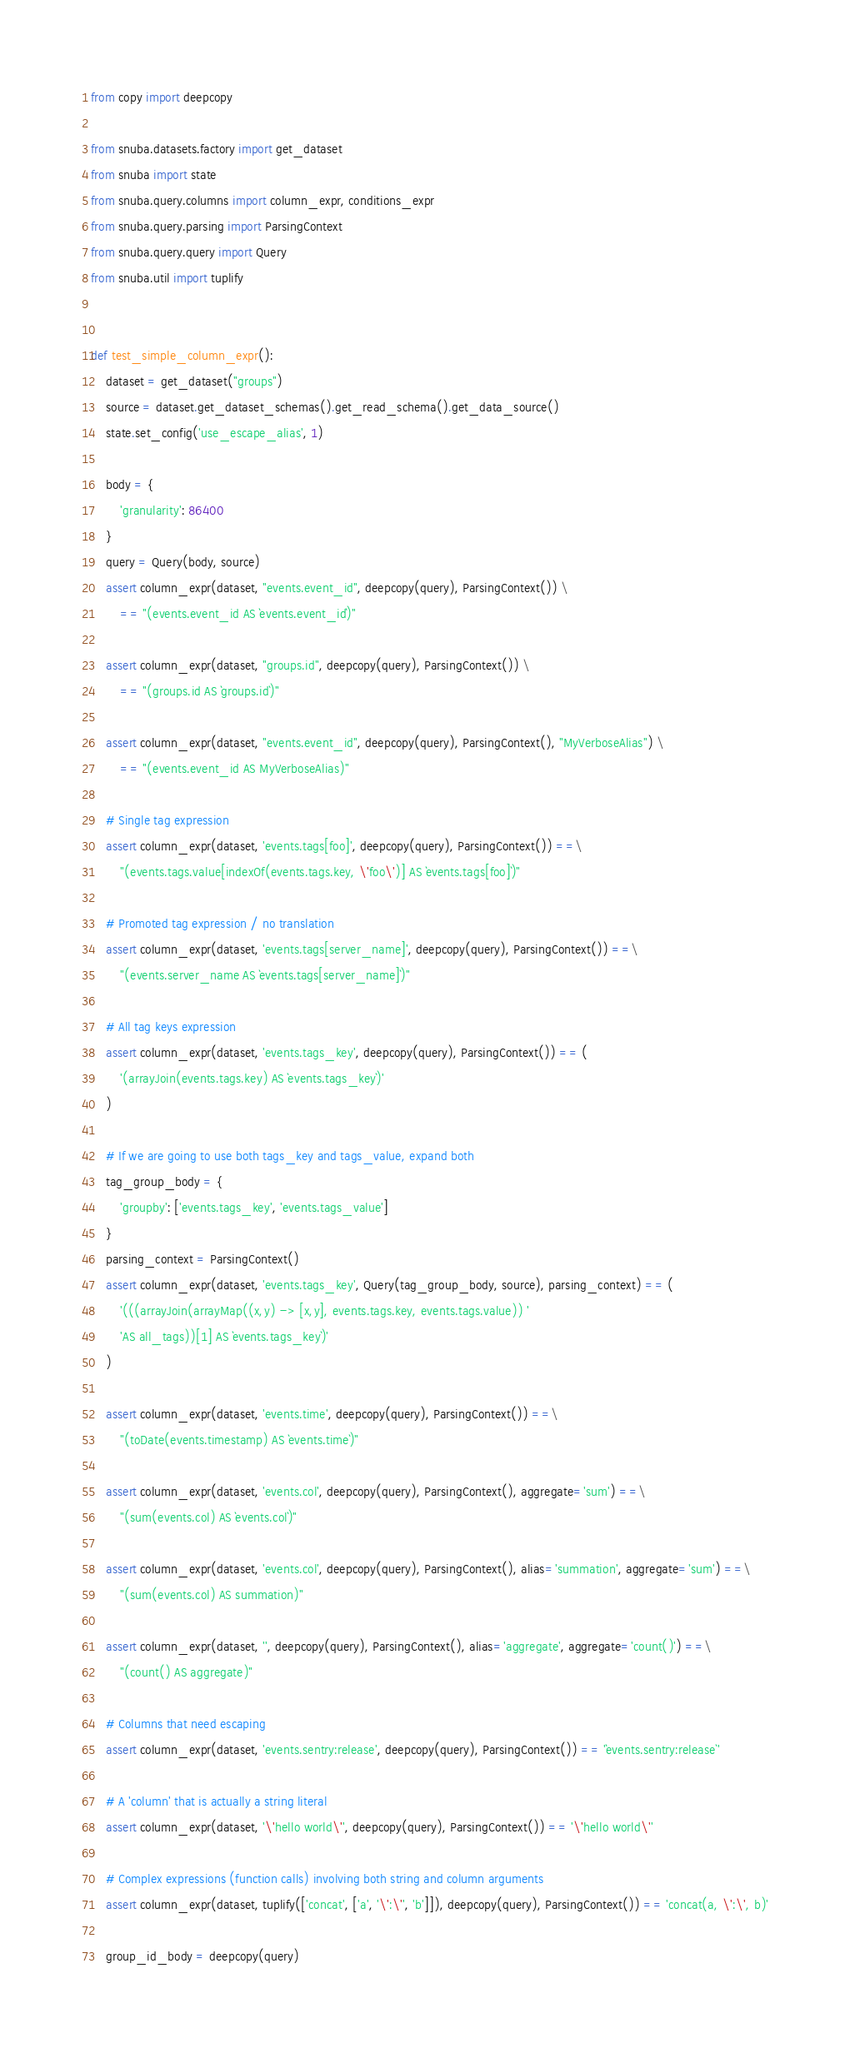<code> <loc_0><loc_0><loc_500><loc_500><_Python_>from copy import deepcopy

from snuba.datasets.factory import get_dataset
from snuba import state
from snuba.query.columns import column_expr, conditions_expr
from snuba.query.parsing import ParsingContext
from snuba.query.query import Query
from snuba.util import tuplify


def test_simple_column_expr():
    dataset = get_dataset("groups")
    source = dataset.get_dataset_schemas().get_read_schema().get_data_source()
    state.set_config('use_escape_alias', 1)

    body = {
        'granularity': 86400
    }
    query = Query(body, source)
    assert column_expr(dataset, "events.event_id", deepcopy(query), ParsingContext()) \
        == "(events.event_id AS `events.event_id`)"

    assert column_expr(dataset, "groups.id", deepcopy(query), ParsingContext()) \
        == "(groups.id AS `groups.id`)"

    assert column_expr(dataset, "events.event_id", deepcopy(query), ParsingContext(), "MyVerboseAlias") \
        == "(events.event_id AS MyVerboseAlias)"

    # Single tag expression
    assert column_expr(dataset, 'events.tags[foo]', deepcopy(query), ParsingContext()) ==\
        "(events.tags.value[indexOf(events.tags.key, \'foo\')] AS `events.tags[foo]`)"

    # Promoted tag expression / no translation
    assert column_expr(dataset, 'events.tags[server_name]', deepcopy(query), ParsingContext()) ==\
        "(events.server_name AS `events.tags[server_name]`)"

    # All tag keys expression
    assert column_expr(dataset, 'events.tags_key', deepcopy(query), ParsingContext()) == (
        '(arrayJoin(events.tags.key) AS `events.tags_key`)'
    )

    # If we are going to use both tags_key and tags_value, expand both
    tag_group_body = {
        'groupby': ['events.tags_key', 'events.tags_value']
    }
    parsing_context = ParsingContext()
    assert column_expr(dataset, 'events.tags_key', Query(tag_group_body, source), parsing_context) == (
        '(((arrayJoin(arrayMap((x,y) -> [x,y], events.tags.key, events.tags.value)) '
        'AS all_tags))[1] AS `events.tags_key`)'
    )

    assert column_expr(dataset, 'events.time', deepcopy(query), ParsingContext()) ==\
        "(toDate(events.timestamp) AS `events.time`)"

    assert column_expr(dataset, 'events.col', deepcopy(query), ParsingContext(), aggregate='sum') ==\
        "(sum(events.col) AS `events.col`)"

    assert column_expr(dataset, 'events.col', deepcopy(query), ParsingContext(), alias='summation', aggregate='sum') ==\
        "(sum(events.col) AS summation)"

    assert column_expr(dataset, '', deepcopy(query), ParsingContext(), alias='aggregate', aggregate='count()') ==\
        "(count() AS aggregate)"

    # Columns that need escaping
    assert column_expr(dataset, 'events.sentry:release', deepcopy(query), ParsingContext()) == '`events.sentry:release`'

    # A 'column' that is actually a string literal
    assert column_expr(dataset, '\'hello world\'', deepcopy(query), ParsingContext()) == '\'hello world\''

    # Complex expressions (function calls) involving both string and column arguments
    assert column_expr(dataset, tuplify(['concat', ['a', '\':\'', 'b']]), deepcopy(query), ParsingContext()) == 'concat(a, \':\', b)'

    group_id_body = deepcopy(query)</code> 